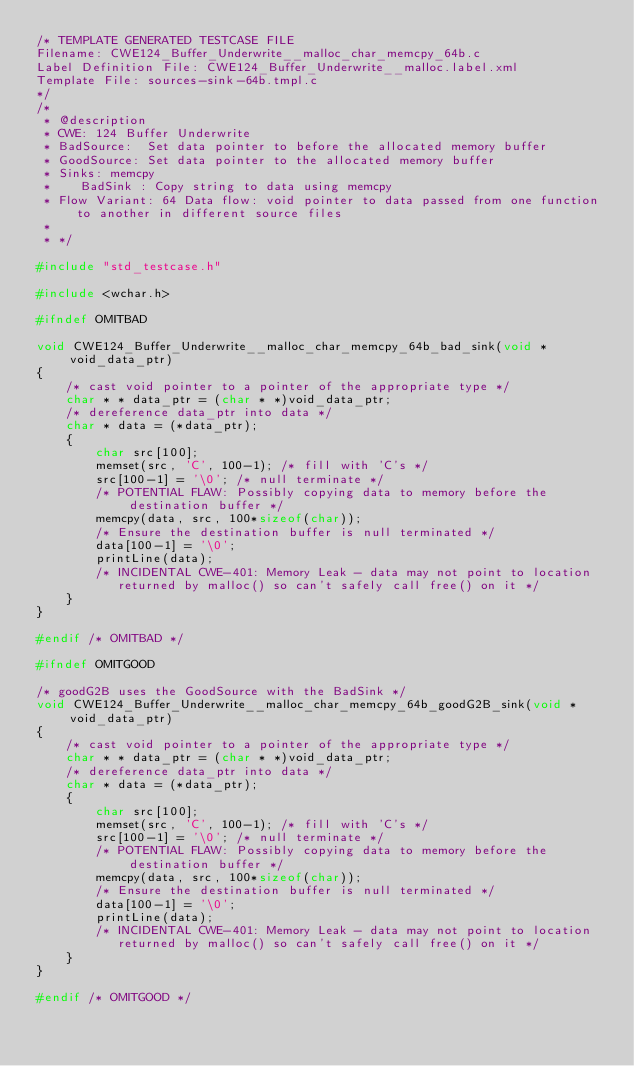<code> <loc_0><loc_0><loc_500><loc_500><_C_>/* TEMPLATE GENERATED TESTCASE FILE
Filename: CWE124_Buffer_Underwrite__malloc_char_memcpy_64b.c
Label Definition File: CWE124_Buffer_Underwrite__malloc.label.xml
Template File: sources-sink-64b.tmpl.c
*/
/*
 * @description
 * CWE: 124 Buffer Underwrite
 * BadSource:  Set data pointer to before the allocated memory buffer
 * GoodSource: Set data pointer to the allocated memory buffer
 * Sinks: memcpy
 *    BadSink : Copy string to data using memcpy
 * Flow Variant: 64 Data flow: void pointer to data passed from one function to another in different source files
 *
 * */

#include "std_testcase.h"

#include <wchar.h>

#ifndef OMITBAD

void CWE124_Buffer_Underwrite__malloc_char_memcpy_64b_bad_sink(void * void_data_ptr)
{
    /* cast void pointer to a pointer of the appropriate type */
    char * * data_ptr = (char * *)void_data_ptr;
    /* dereference data_ptr into data */
    char * data = (*data_ptr);
    {
        char src[100];
        memset(src, 'C', 100-1); /* fill with 'C's */
        src[100-1] = '\0'; /* null terminate */
        /* POTENTIAL FLAW: Possibly copying data to memory before the destination buffer */
        memcpy(data, src, 100*sizeof(char));
        /* Ensure the destination buffer is null terminated */
        data[100-1] = '\0';
        printLine(data);
        /* INCIDENTAL CWE-401: Memory Leak - data may not point to location
           returned by malloc() so can't safely call free() on it */
    }
}

#endif /* OMITBAD */

#ifndef OMITGOOD

/* goodG2B uses the GoodSource with the BadSink */
void CWE124_Buffer_Underwrite__malloc_char_memcpy_64b_goodG2B_sink(void * void_data_ptr)
{
    /* cast void pointer to a pointer of the appropriate type */
    char * * data_ptr = (char * *)void_data_ptr;
    /* dereference data_ptr into data */
    char * data = (*data_ptr);
    {
        char src[100];
        memset(src, 'C', 100-1); /* fill with 'C's */
        src[100-1] = '\0'; /* null terminate */
        /* POTENTIAL FLAW: Possibly copying data to memory before the destination buffer */
        memcpy(data, src, 100*sizeof(char));
        /* Ensure the destination buffer is null terminated */
        data[100-1] = '\0';
        printLine(data);
        /* INCIDENTAL CWE-401: Memory Leak - data may not point to location
           returned by malloc() so can't safely call free() on it */
    }
}

#endif /* OMITGOOD */
</code> 